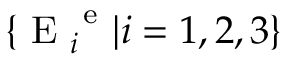<formula> <loc_0><loc_0><loc_500><loc_500>\{ E _ { i } ^ { e } | i = 1 , 2 , 3 \}</formula> 